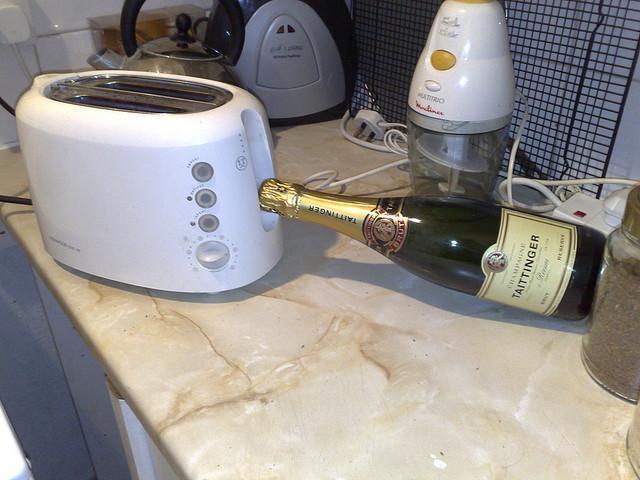How many toasters are in the photo?
Give a very brief answer. 1. 